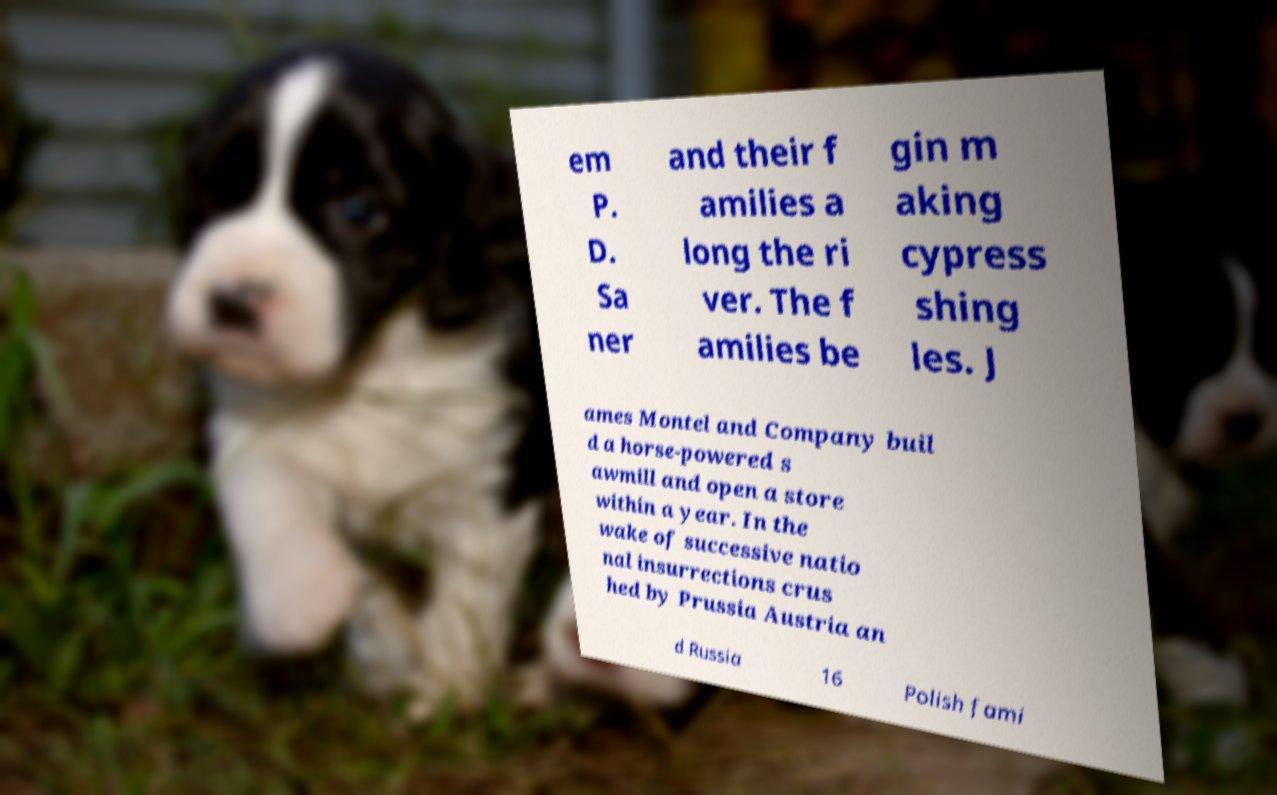Can you read and provide the text displayed in the image?This photo seems to have some interesting text. Can you extract and type it out for me? em P. D. Sa ner and their f amilies a long the ri ver. The f amilies be gin m aking cypress shing les. J ames Montel and Company buil d a horse-powered s awmill and open a store within a year. In the wake of successive natio nal insurrections crus hed by Prussia Austria an d Russia 16 Polish fami 